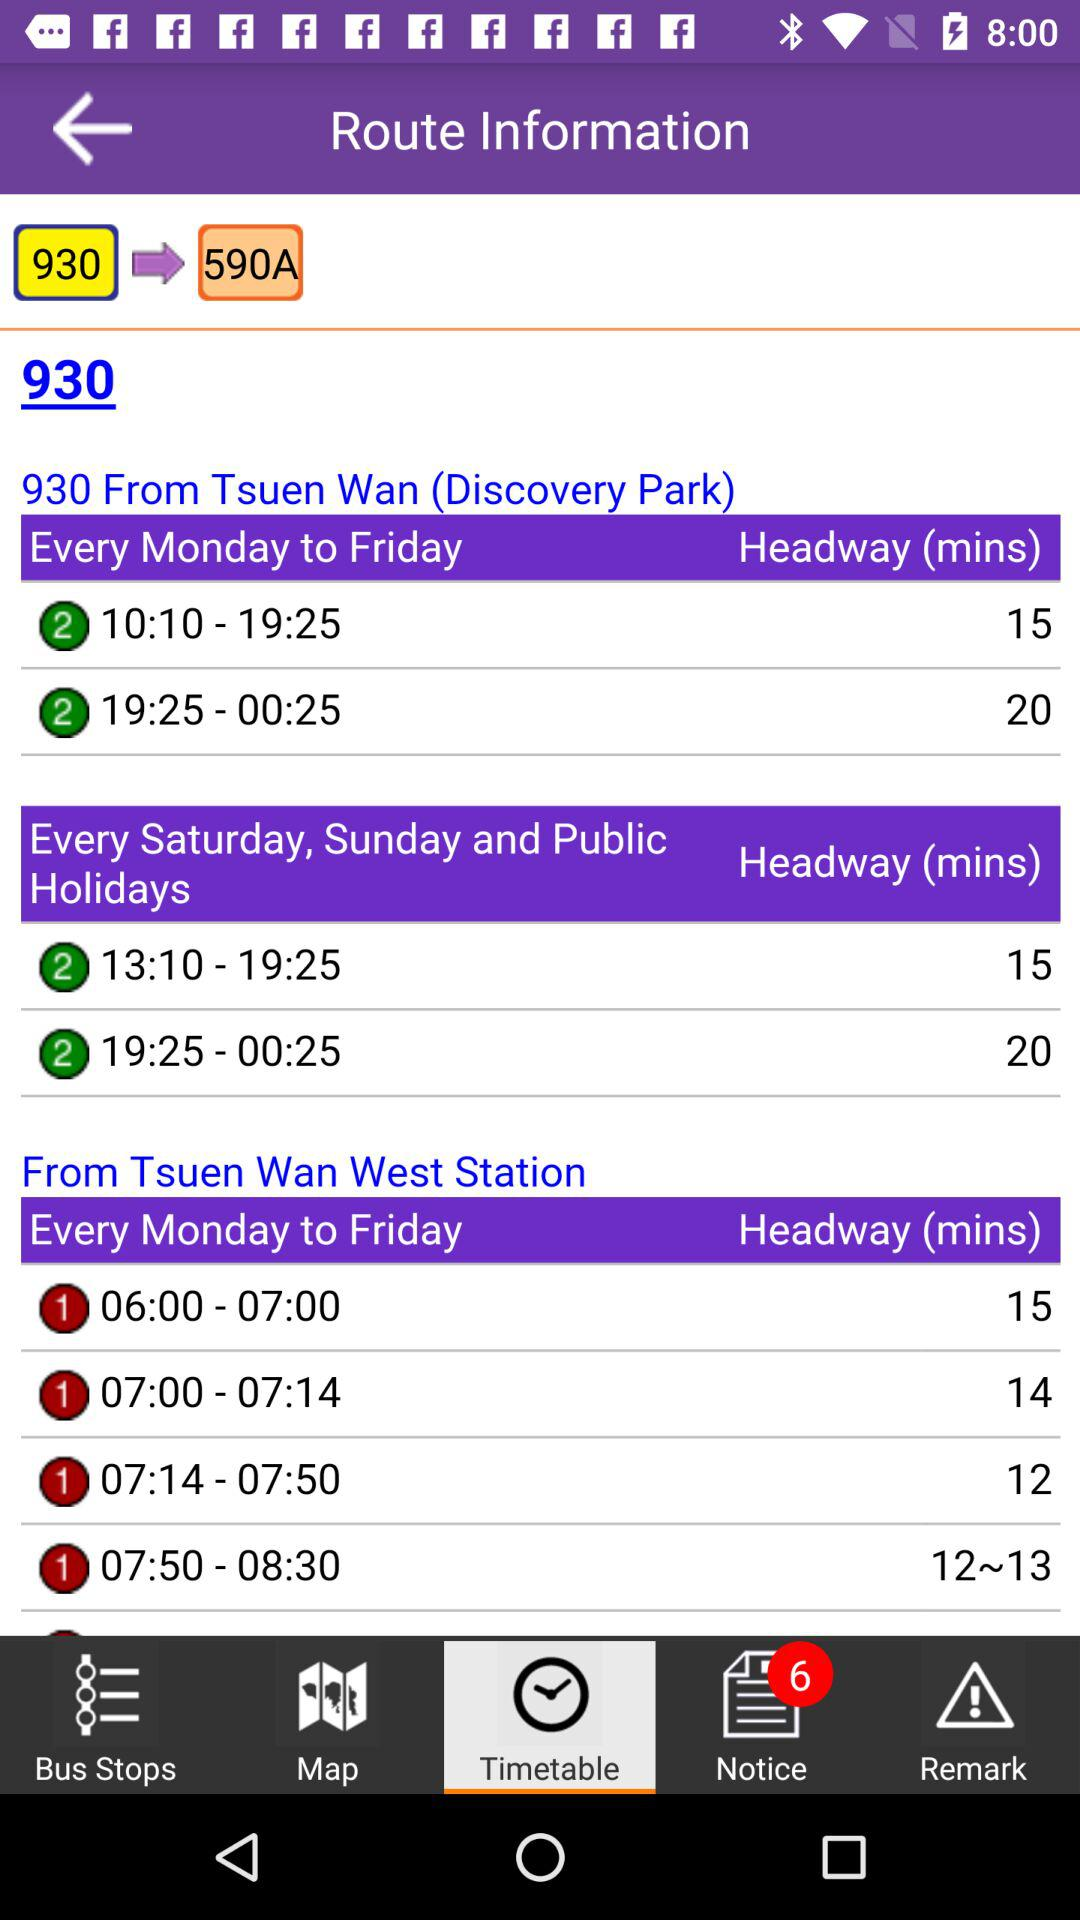Discovery Park is also known as which place?
When the provided information is insufficient, respond with <no answer>. <no answer> 